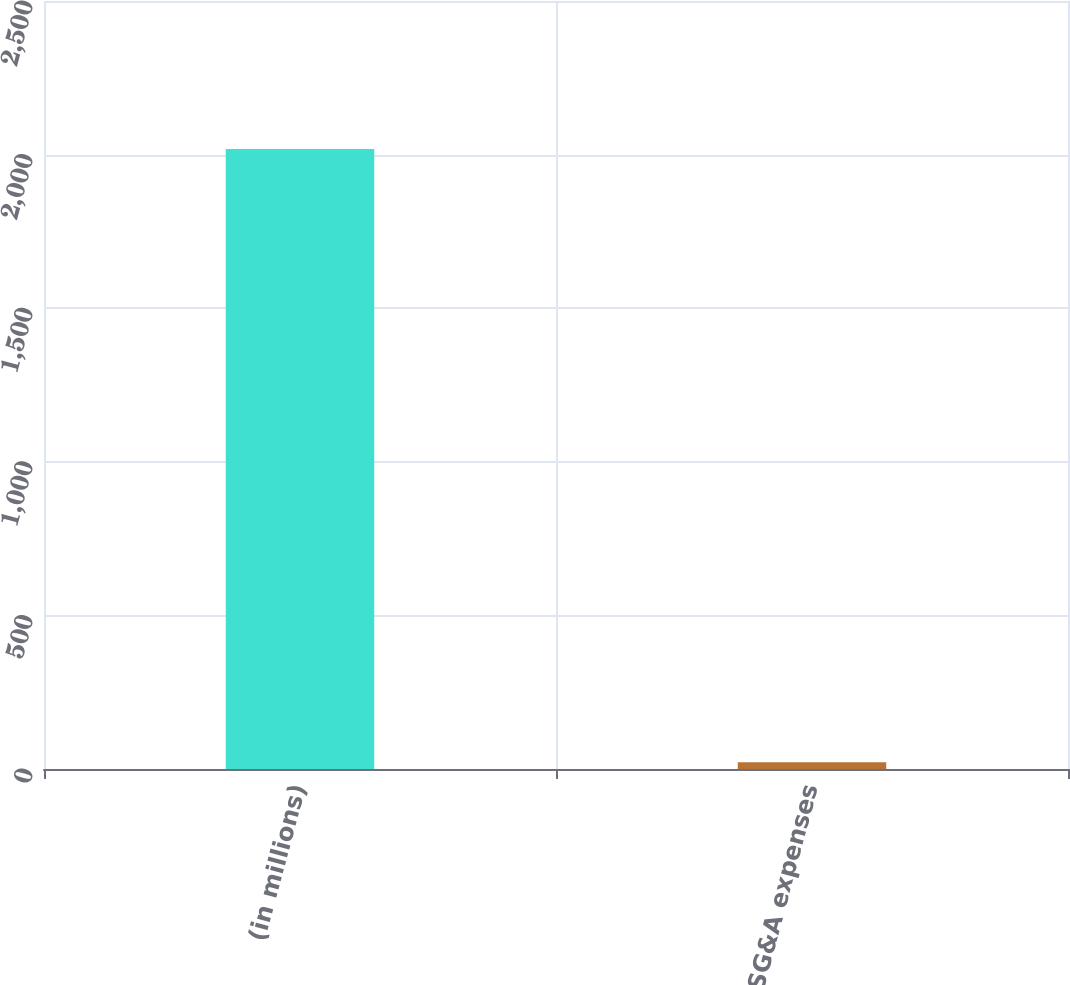Convert chart to OTSL. <chart><loc_0><loc_0><loc_500><loc_500><bar_chart><fcel>(in millions)<fcel>SG&A expenses<nl><fcel>2018<fcel>22<nl></chart> 